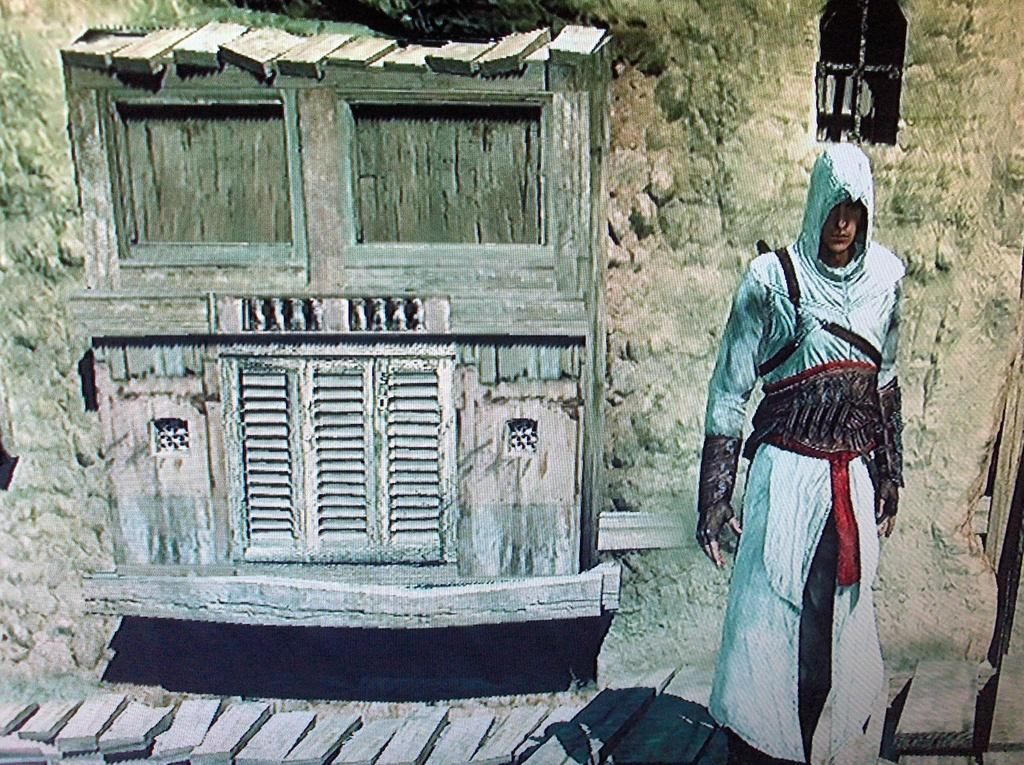Who is present in the image? There is a man in the image. What can be seen through the window in the image? The image does not show what can be seen through the window. What is the man standing next to in the image? The man is standing next to a wall in the image. What architectural feature is visible in the image? There are stairs in the image. What type of outdoor feature is present in the image? There is a pathway in the image. What type of pencil is the man holding in the image? There is no pencil present in the image. What insect is crawling on the man's shoulder in the image? There is no insect visible on the man's shoulder in the image. 